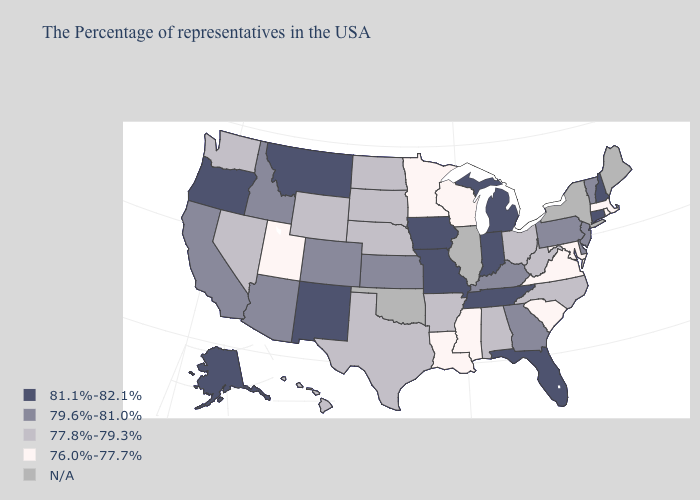Does South Dakota have the lowest value in the USA?
Answer briefly. No. Among the states that border Rhode Island , which have the highest value?
Give a very brief answer. Connecticut. Does Rhode Island have the lowest value in the Northeast?
Write a very short answer. Yes. What is the value of Colorado?
Answer briefly. 79.6%-81.0%. What is the value of Idaho?
Quick response, please. 79.6%-81.0%. Name the states that have a value in the range 79.6%-81.0%?
Quick response, please. Vermont, New Jersey, Delaware, Pennsylvania, Georgia, Kentucky, Kansas, Colorado, Arizona, Idaho, California. Does the first symbol in the legend represent the smallest category?
Give a very brief answer. No. What is the value of Iowa?
Answer briefly. 81.1%-82.1%. Is the legend a continuous bar?
Write a very short answer. No. Does New Jersey have the lowest value in the USA?
Answer briefly. No. What is the value of New Hampshire?
Answer briefly. 81.1%-82.1%. Name the states that have a value in the range 79.6%-81.0%?
Be succinct. Vermont, New Jersey, Delaware, Pennsylvania, Georgia, Kentucky, Kansas, Colorado, Arizona, Idaho, California. 